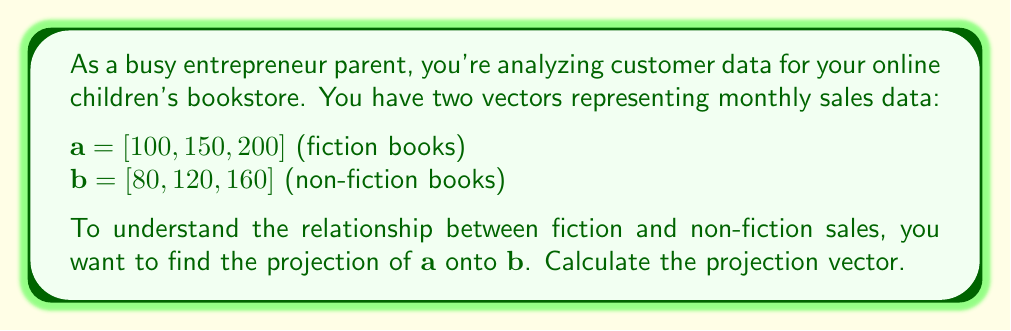What is the answer to this math problem? To find the projection of $\mathbf{a}$ onto $\mathbf{b}$, we'll use the formula:

$$\text{proj}_\mathbf{b}\mathbf{a} = \frac{\mathbf{a} \cdot \mathbf{b}}{\|\mathbf{b}\|^2} \mathbf{b}$$

Step 1: Calculate the dot product $\mathbf{a} \cdot \mathbf{b}$
$\mathbf{a} \cdot \mathbf{b} = (100)(80) + (150)(120) + (200)(160) = 8000 + 18000 + 32000 = 58000$

Step 2: Calculate $\|\mathbf{b}\|^2$
$\|\mathbf{b}\|^2 = 80^2 + 120^2 + 160^2 = 6400 + 14400 + 25600 = 46400$

Step 3: Calculate the scalar projection
$\frac{\mathbf{a} \cdot \mathbf{b}}{\|\mathbf{b}\|^2} = \frac{58000}{46400} = \frac{125}{100} = 1.25$

Step 4: Multiply the scalar projection by $\mathbf{b}$
$\text{proj}_\mathbf{b}\mathbf{a} = 1.25 \mathbf{b} = 1.25[80, 120, 160] = [100, 150, 200]$
Answer: $[100, 150, 200]$ 